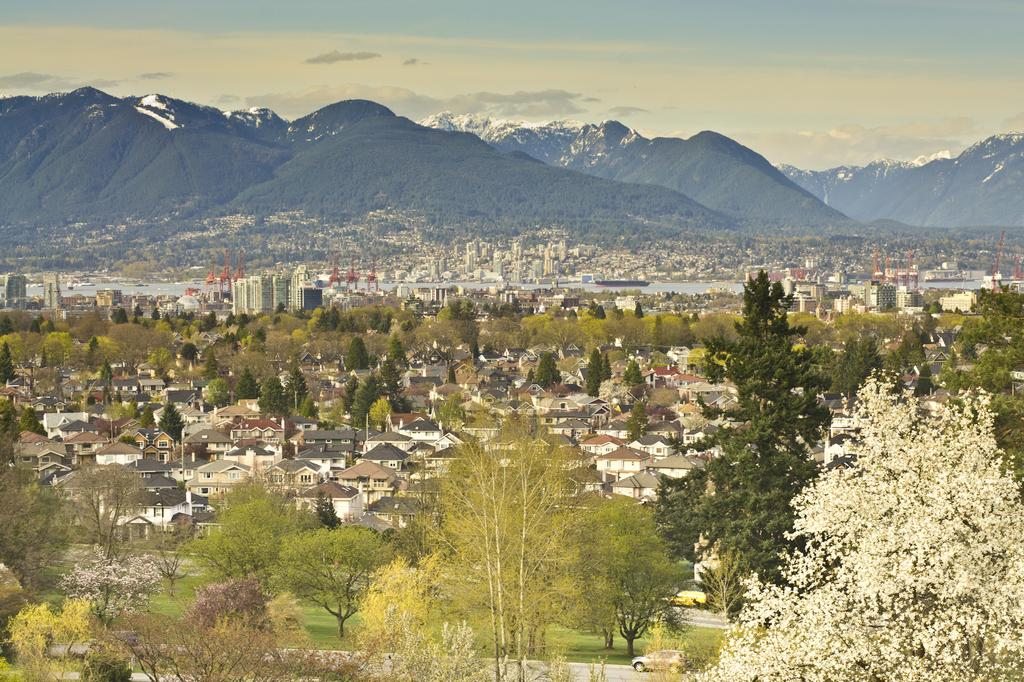What type of natural elements can be seen in the image? There are trees in the image. What type of man-made structures are present in the image? There are buildings in the image. What can be seen in the distance in the image? Mountains are visible in the background of the image. What is visible above the trees and buildings in the image? The sky is visible in the background of the image. How many rings can be seen on the lizard's tail in the image? There are no lizards or rings present in the image. What type of force is used to pull the mountains closer together in the image? There is no force being applied to the mountains in the image; they are simply visible in the background. 